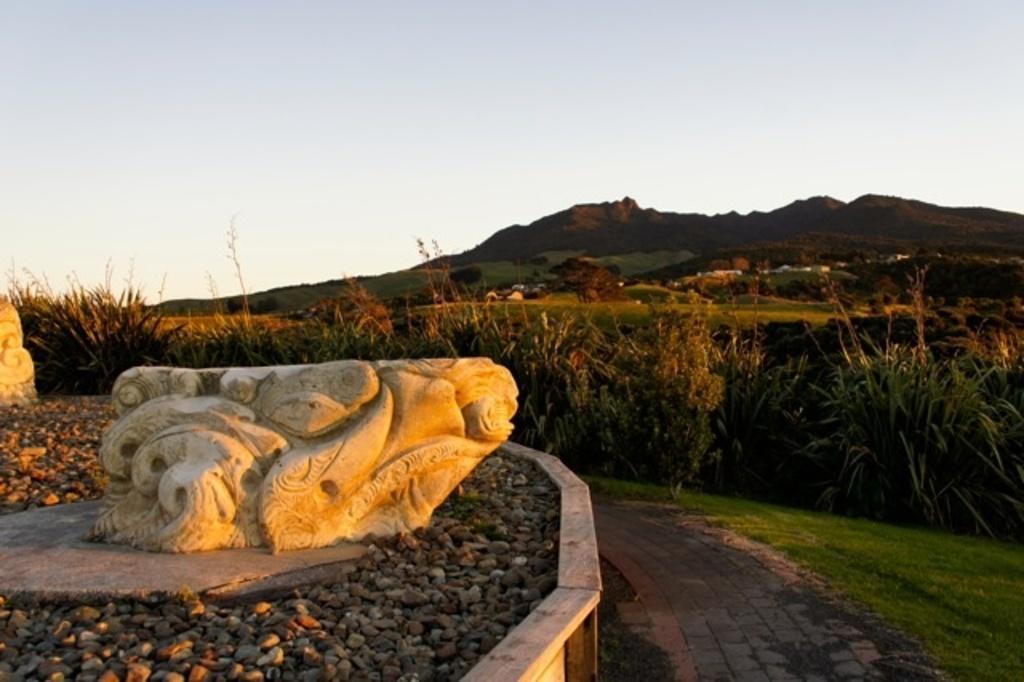Please provide a concise description of this image. In this image we can see few sculptures. There are many pebbles in the image. There are many trees and plants in the image. We can see the sky in the image. There are few houses in the image. There is a grassy land in the image. 